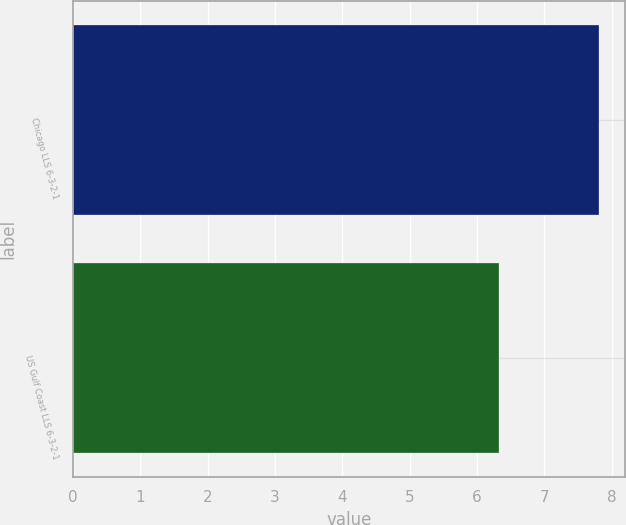Convert chart. <chart><loc_0><loc_0><loc_500><loc_500><bar_chart><fcel>Chicago LLS 6-3-2-1<fcel>US Gulf Coast LLS 6-3-2-1<nl><fcel>7.81<fcel>6.32<nl></chart> 